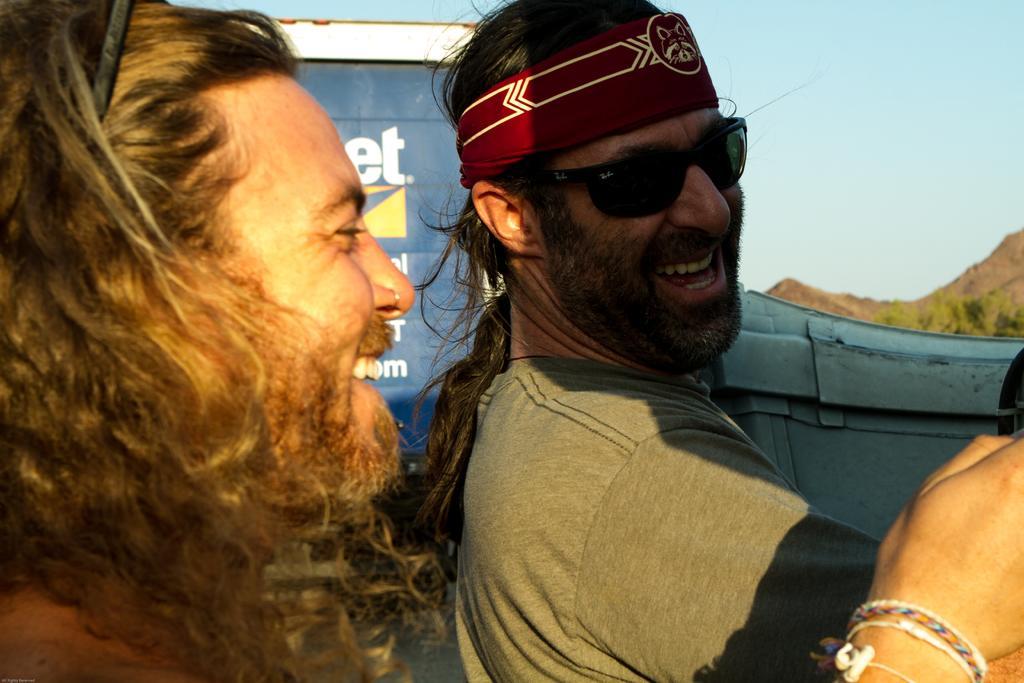How would you summarize this image in a sentence or two? This picture is clicked outside. On the right there is a man wearing goggles, t-shirt and smiling. On the left there is another man smiling and in the background we can see the sky, hills and the text on a blue color object and some other objects. 